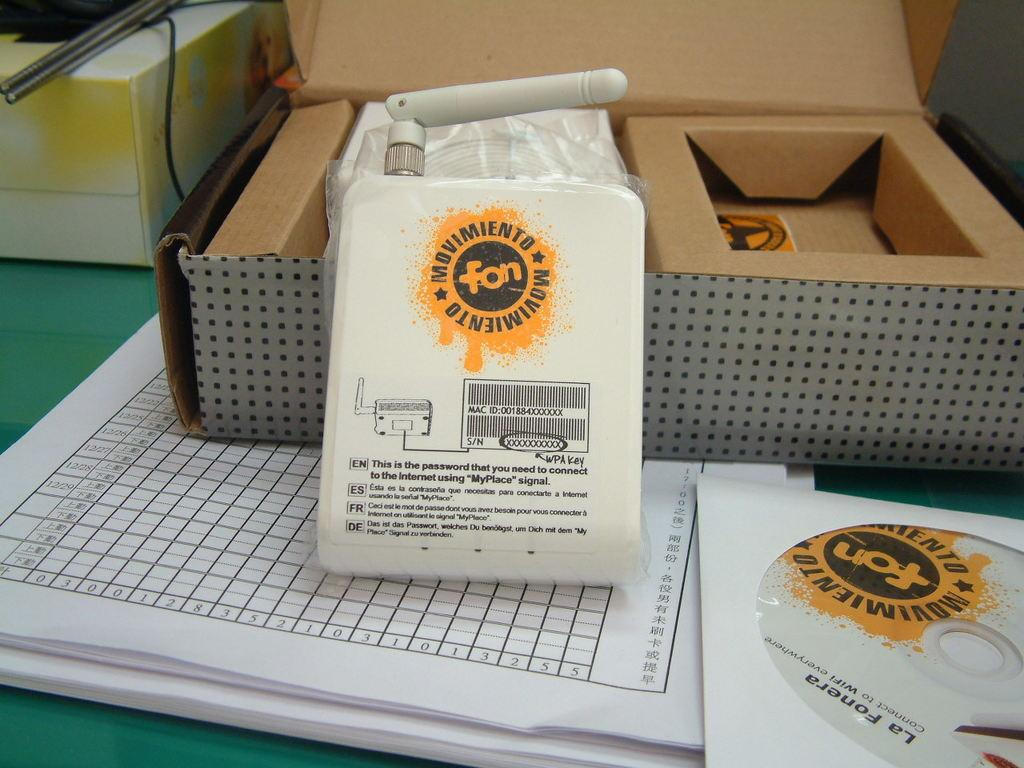Provide a one-sentence caption for the provided image. An open box with a white package in front of it that says Movimiento with a yellow label. 